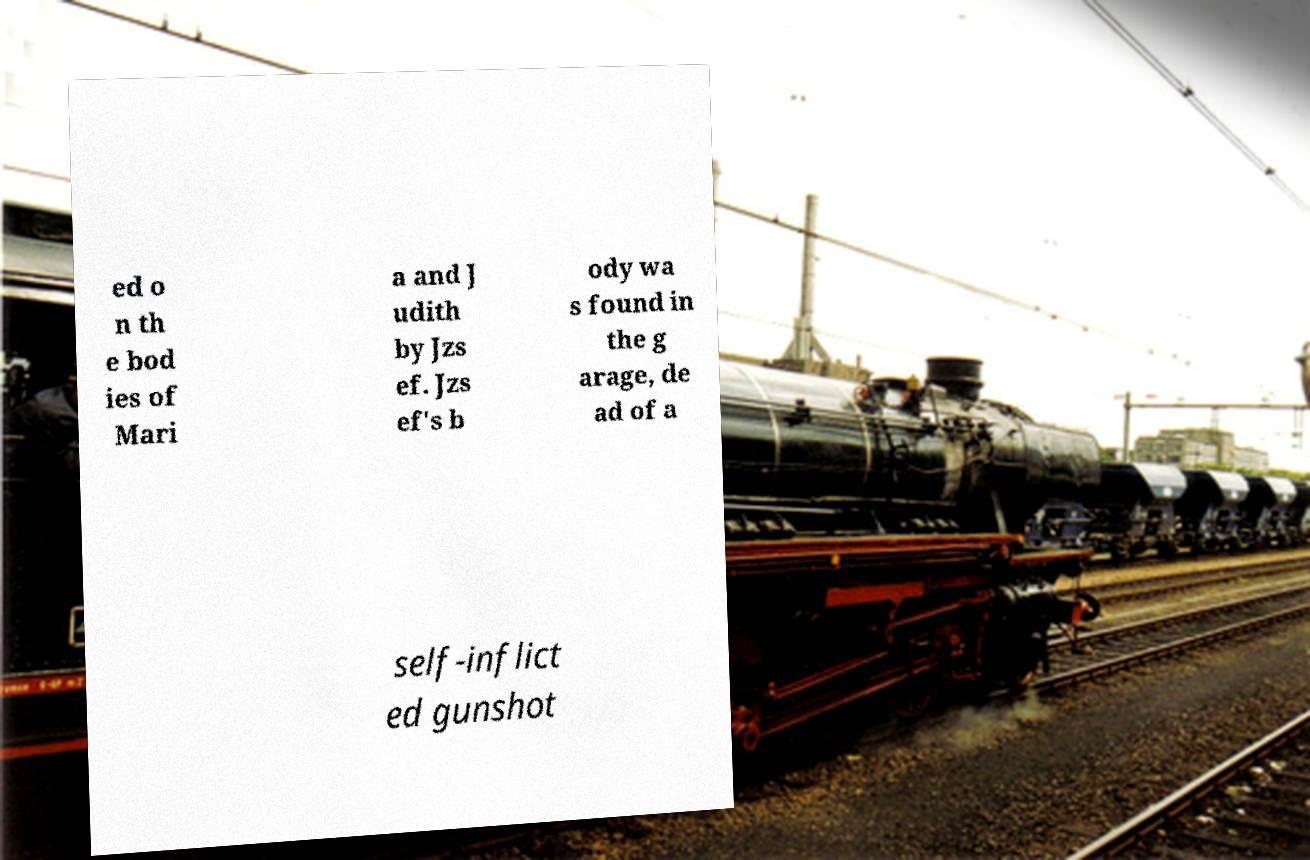Can you accurately transcribe the text from the provided image for me? ed o n th e bod ies of Mari a and J udith by Jzs ef. Jzs ef's b ody wa s found in the g arage, de ad of a self-inflict ed gunshot 